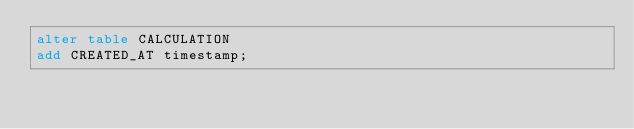Convert code to text. <code><loc_0><loc_0><loc_500><loc_500><_SQL_>alter table CALCULATION
add CREATED_AT timestamp;
</code> 